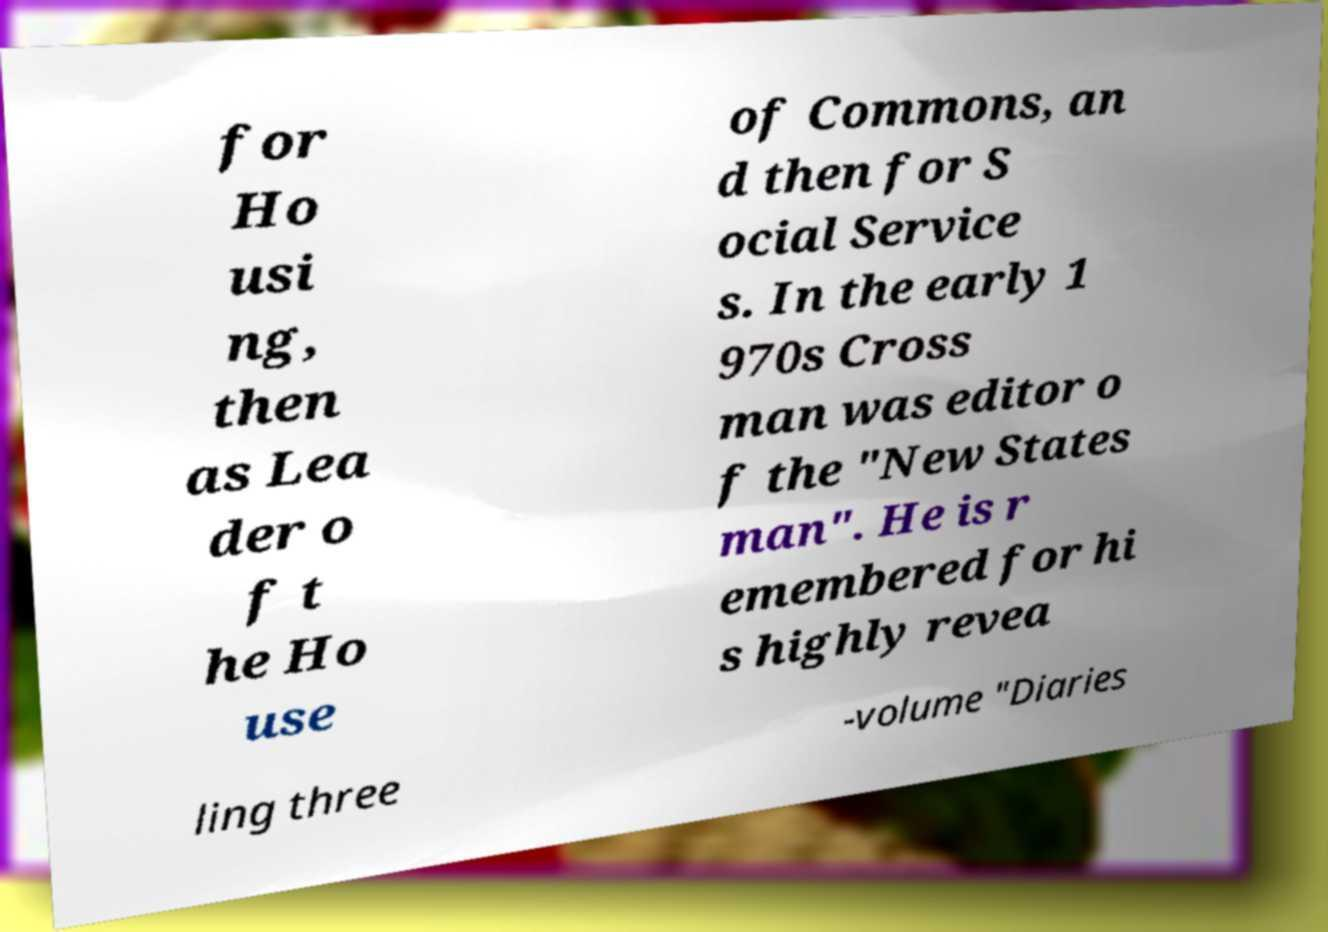I need the written content from this picture converted into text. Can you do that? for Ho usi ng, then as Lea der o f t he Ho use of Commons, an d then for S ocial Service s. In the early 1 970s Cross man was editor o f the "New States man". He is r emembered for hi s highly revea ling three -volume "Diaries 